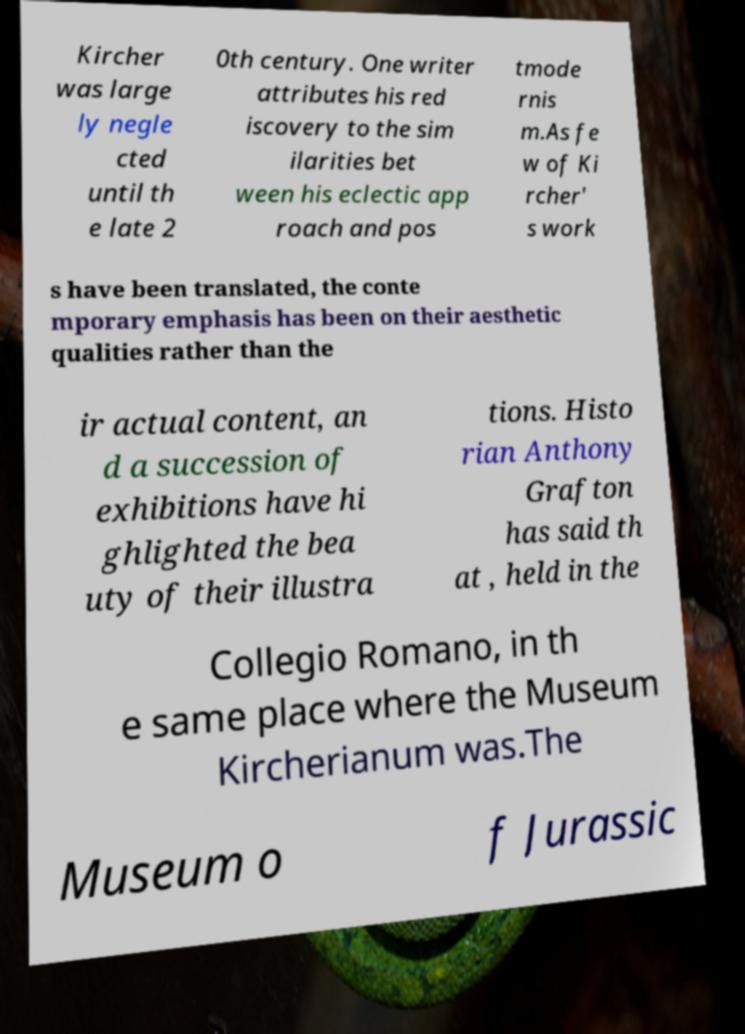For documentation purposes, I need the text within this image transcribed. Could you provide that? Kircher was large ly negle cted until th e late 2 0th century. One writer attributes his red iscovery to the sim ilarities bet ween his eclectic app roach and pos tmode rnis m.As fe w of Ki rcher' s work s have been translated, the conte mporary emphasis has been on their aesthetic qualities rather than the ir actual content, an d a succession of exhibitions have hi ghlighted the bea uty of their illustra tions. Histo rian Anthony Grafton has said th at , held in the Collegio Romano, in th e same place where the Museum Kircherianum was.The Museum o f Jurassic 